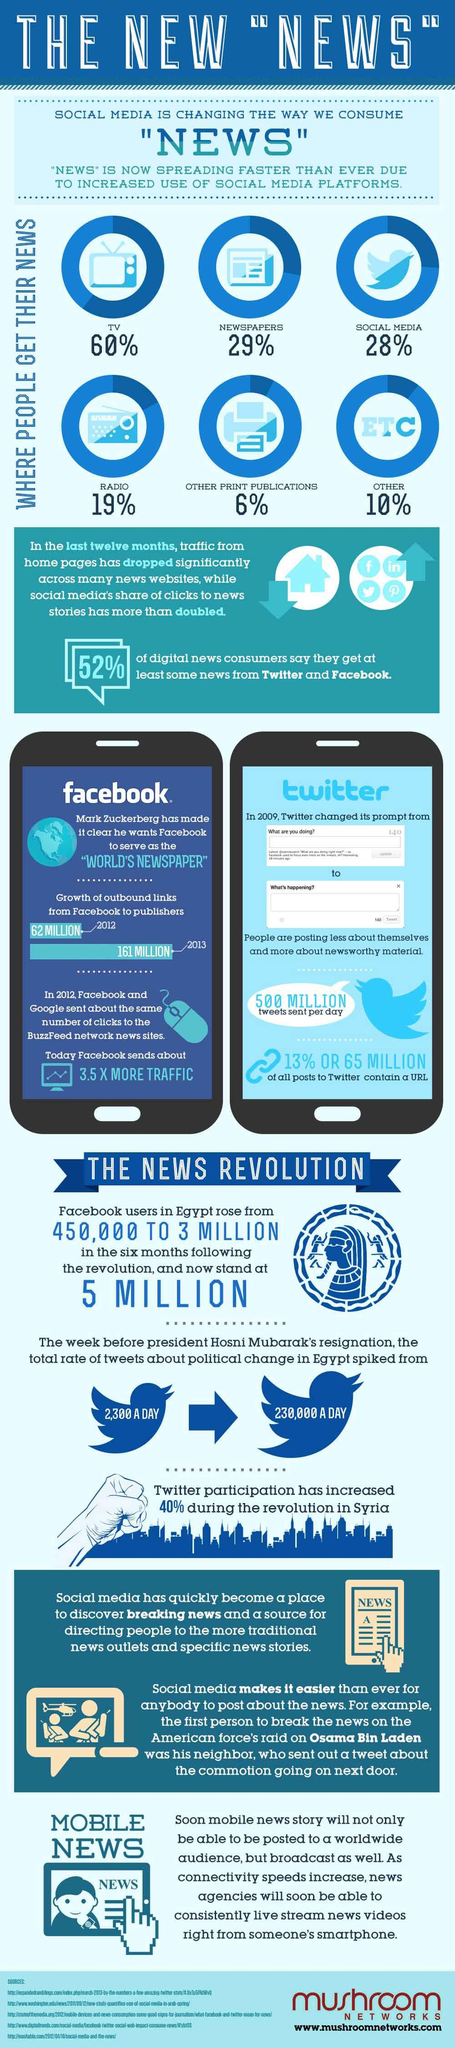Point out several critical features in this image. According to a recent survey, 28% of people get their news through social media. The majority of people obtain their news from television. In 2009, approximately 500 million Tweets were sent per day. In 2013, the number of outbound links from Facebook to publishers was approximately 161 million. According to a recent survey, 19% of people get their news through radio. 